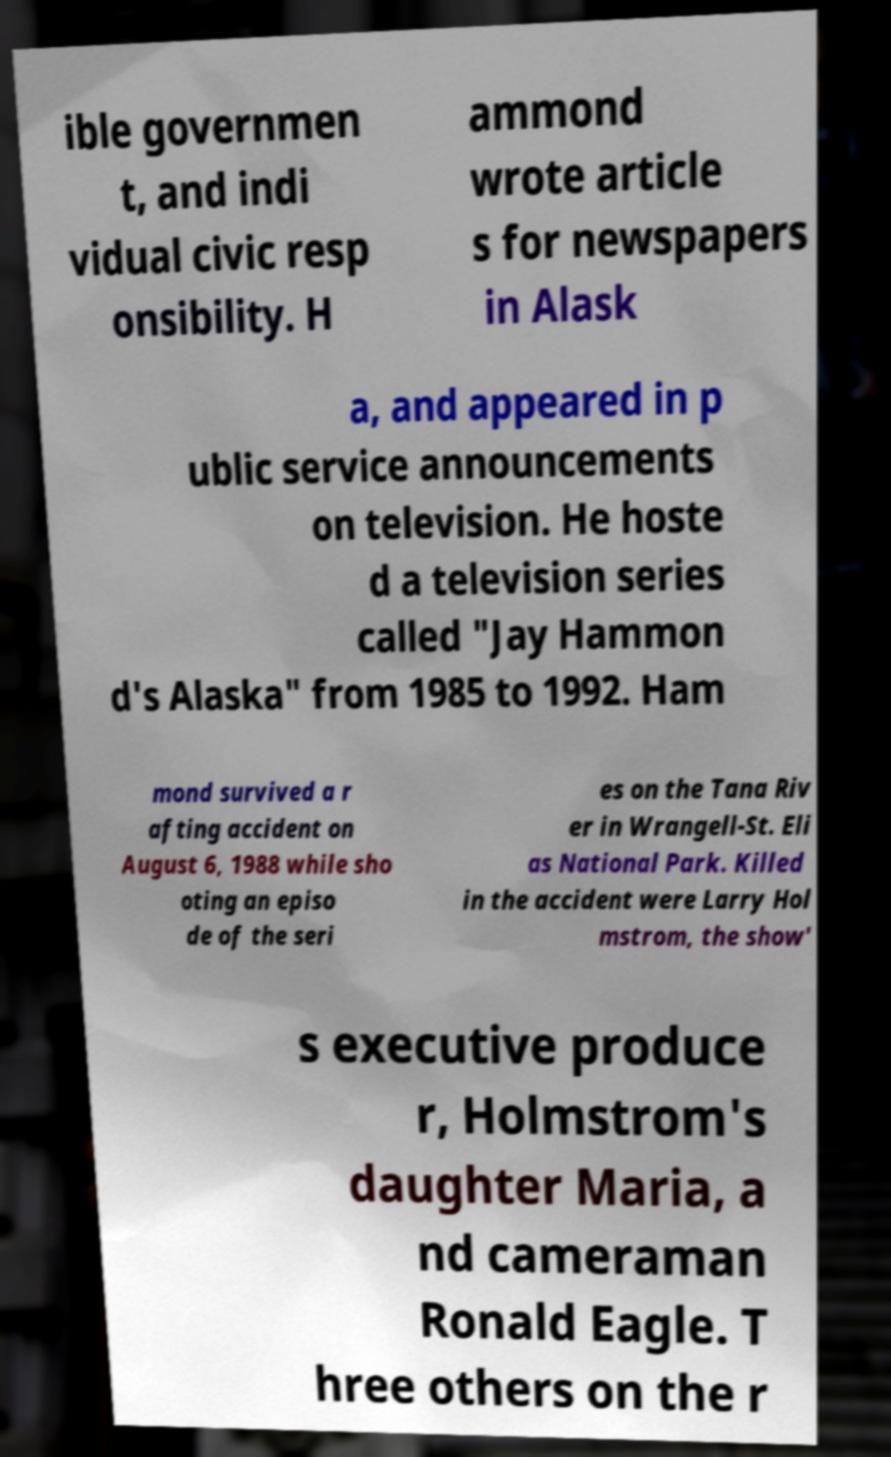There's text embedded in this image that I need extracted. Can you transcribe it verbatim? ible governmen t, and indi vidual civic resp onsibility. H ammond wrote article s for newspapers in Alask a, and appeared in p ublic service announcements on television. He hoste d a television series called "Jay Hammon d's Alaska" from 1985 to 1992. Ham mond survived a r afting accident on August 6, 1988 while sho oting an episo de of the seri es on the Tana Riv er in Wrangell-St. Eli as National Park. Killed in the accident were Larry Hol mstrom, the show' s executive produce r, Holmstrom's daughter Maria, a nd cameraman Ronald Eagle. T hree others on the r 